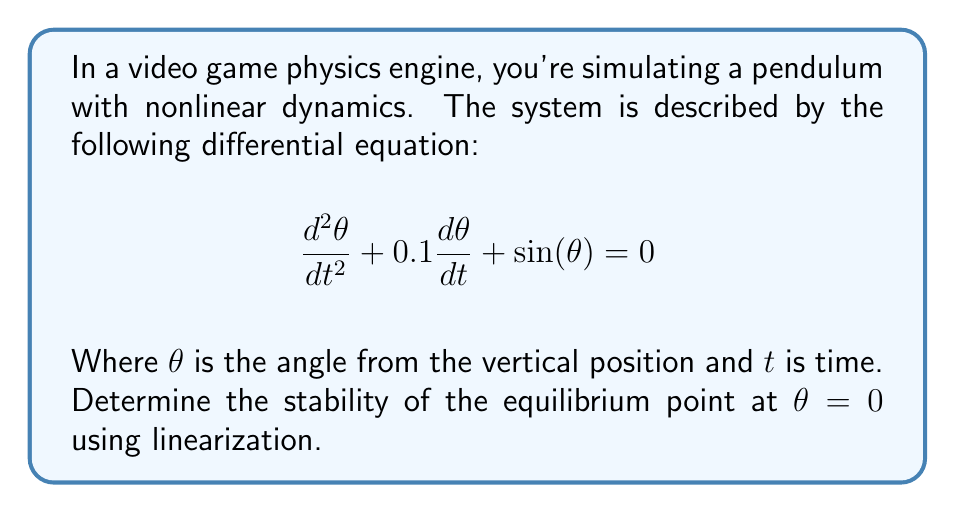Provide a solution to this math problem. To determine the stability of the nonlinear system at the equilibrium point $\theta = 0$, we'll follow these steps:

1. Rewrite the system as a first-order system:
   Let $x_1 = \theta$ and $x_2 = \frac{d\theta}{dt}$. Then:
   $$\frac{dx_1}{dt} = x_2$$
   $$\frac{dx_2}{dt} = -0.1x_2 - \sin(x_1)$$

2. Find the Jacobian matrix:
   $$J = \begin{bmatrix}
   \frac{\partial f_1}{\partial x_1} & \frac{\partial f_1}{\partial x_2} \\
   \frac{\partial f_2}{\partial x_1} & \frac{\partial f_2}{\partial x_2}
   \end{bmatrix} = \begin{bmatrix}
   0 & 1 \\
   -\cos(x_1) & -0.1
   \end{bmatrix}$$

3. Evaluate the Jacobian at the equilibrium point $(0, 0)$:
   $$J(0,0) = \begin{bmatrix}
   0 & 1 \\
   -1 & -0.1
   \end{bmatrix}$$

4. Calculate the eigenvalues of $J(0,0)$:
   $$\det(J(0,0) - \lambda I) = \det\begin{bmatrix}
   -\lambda & 1 \\
   -1 & -0.1-\lambda
   \end{bmatrix} = 0$$
   
   $$\lambda^2 + 0.1\lambda + 1 = 0$$

   Using the quadratic formula:
   $$\lambda = \frac{-0.1 \pm \sqrt{0.01 - 4}}{2} = -0.05 \pm 0.9987i$$

5. Analyze the eigenvalues:
   Both eigenvalues have negative real parts (-0.05), indicating that the equilibrium point is asymptotically stable.
Answer: Asymptotically stable 